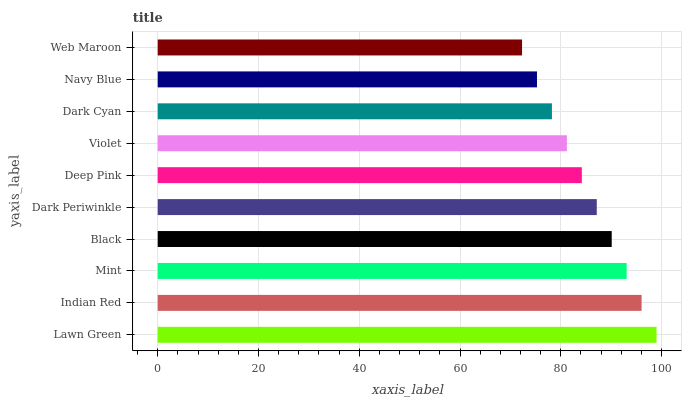Is Web Maroon the minimum?
Answer yes or no. Yes. Is Lawn Green the maximum?
Answer yes or no. Yes. Is Indian Red the minimum?
Answer yes or no. No. Is Indian Red the maximum?
Answer yes or no. No. Is Lawn Green greater than Indian Red?
Answer yes or no. Yes. Is Indian Red less than Lawn Green?
Answer yes or no. Yes. Is Indian Red greater than Lawn Green?
Answer yes or no. No. Is Lawn Green less than Indian Red?
Answer yes or no. No. Is Dark Periwinkle the high median?
Answer yes or no. Yes. Is Deep Pink the low median?
Answer yes or no. Yes. Is Lawn Green the high median?
Answer yes or no. No. Is Navy Blue the low median?
Answer yes or no. No. 